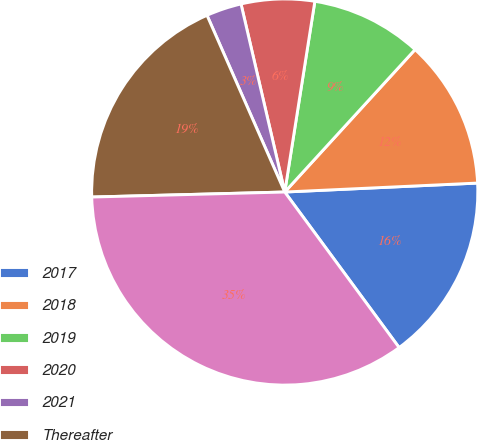<chart> <loc_0><loc_0><loc_500><loc_500><pie_chart><fcel>2017<fcel>2018<fcel>2019<fcel>2020<fcel>2021<fcel>Thereafter<fcel>Total minimum lease payments<nl><fcel>15.65%<fcel>12.47%<fcel>9.3%<fcel>6.13%<fcel>2.96%<fcel>18.82%<fcel>34.68%<nl></chart> 